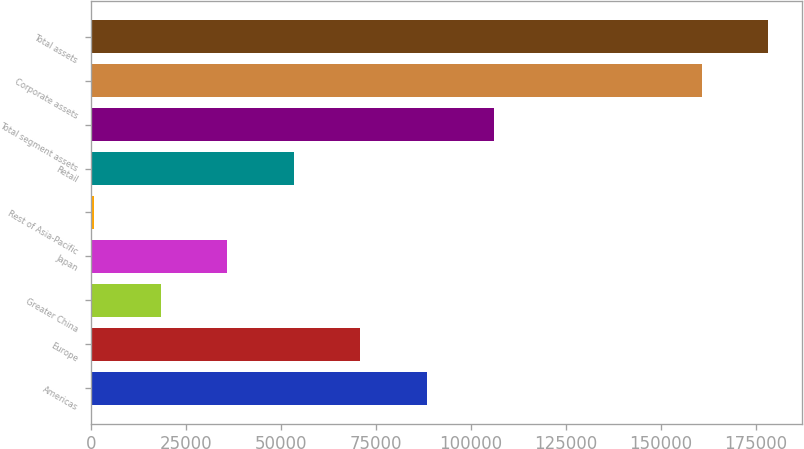Convert chart. <chart><loc_0><loc_0><loc_500><loc_500><bar_chart><fcel>Americas<fcel>Europe<fcel>Greater China<fcel>Japan<fcel>Rest of Asia-Pacific<fcel>Retail<fcel>Total segment assets<fcel>Corporate assets<fcel>Total assets<nl><fcel>88488.5<fcel>70973.4<fcel>18428.1<fcel>35943.2<fcel>913<fcel>53458.3<fcel>106004<fcel>160787<fcel>178302<nl></chart> 